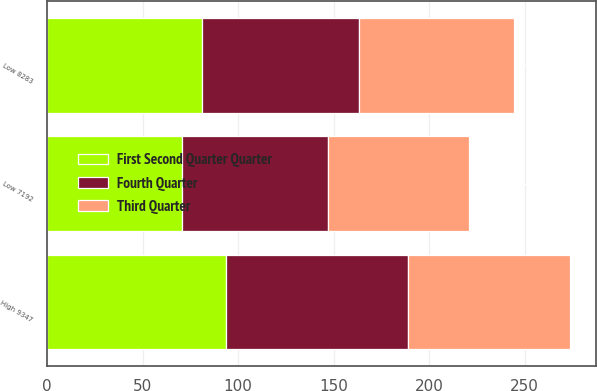Convert chart to OTSL. <chart><loc_0><loc_0><loc_500><loc_500><stacked_bar_chart><ecel><fcel>High 9347<fcel>Low 8283<fcel>Low 7192<nl><fcel>Fourth Quarter<fcel>95.05<fcel>82.56<fcel>76.51<nl><fcel>First Second Quarter Quarter<fcel>93.77<fcel>80.9<fcel>70.59<nl><fcel>Third Quarter<fcel>85.1<fcel>80.99<fcel>73.81<nl></chart> 